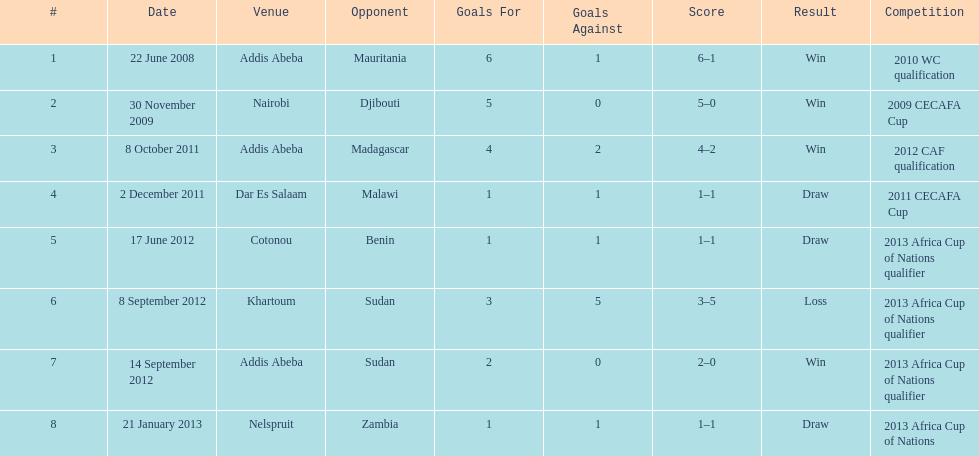For each winning game, what was their score? 6-1, 5-0, 4-2, 2-0. 